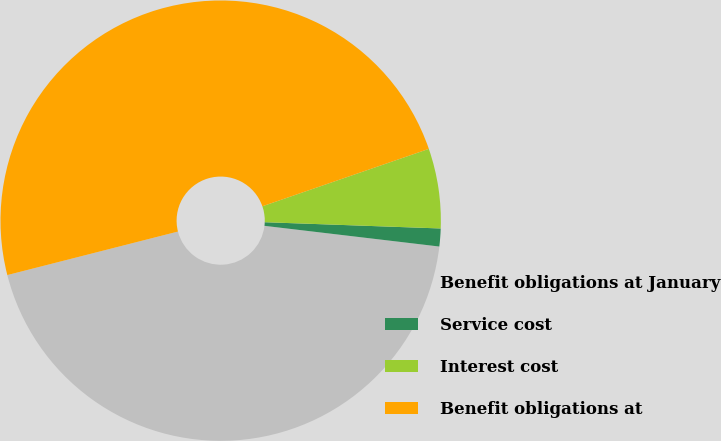<chart> <loc_0><loc_0><loc_500><loc_500><pie_chart><fcel>Benefit obligations at January<fcel>Service cost<fcel>Interest cost<fcel>Benefit obligations at<nl><fcel>44.15%<fcel>1.31%<fcel>5.85%<fcel>48.69%<nl></chart> 